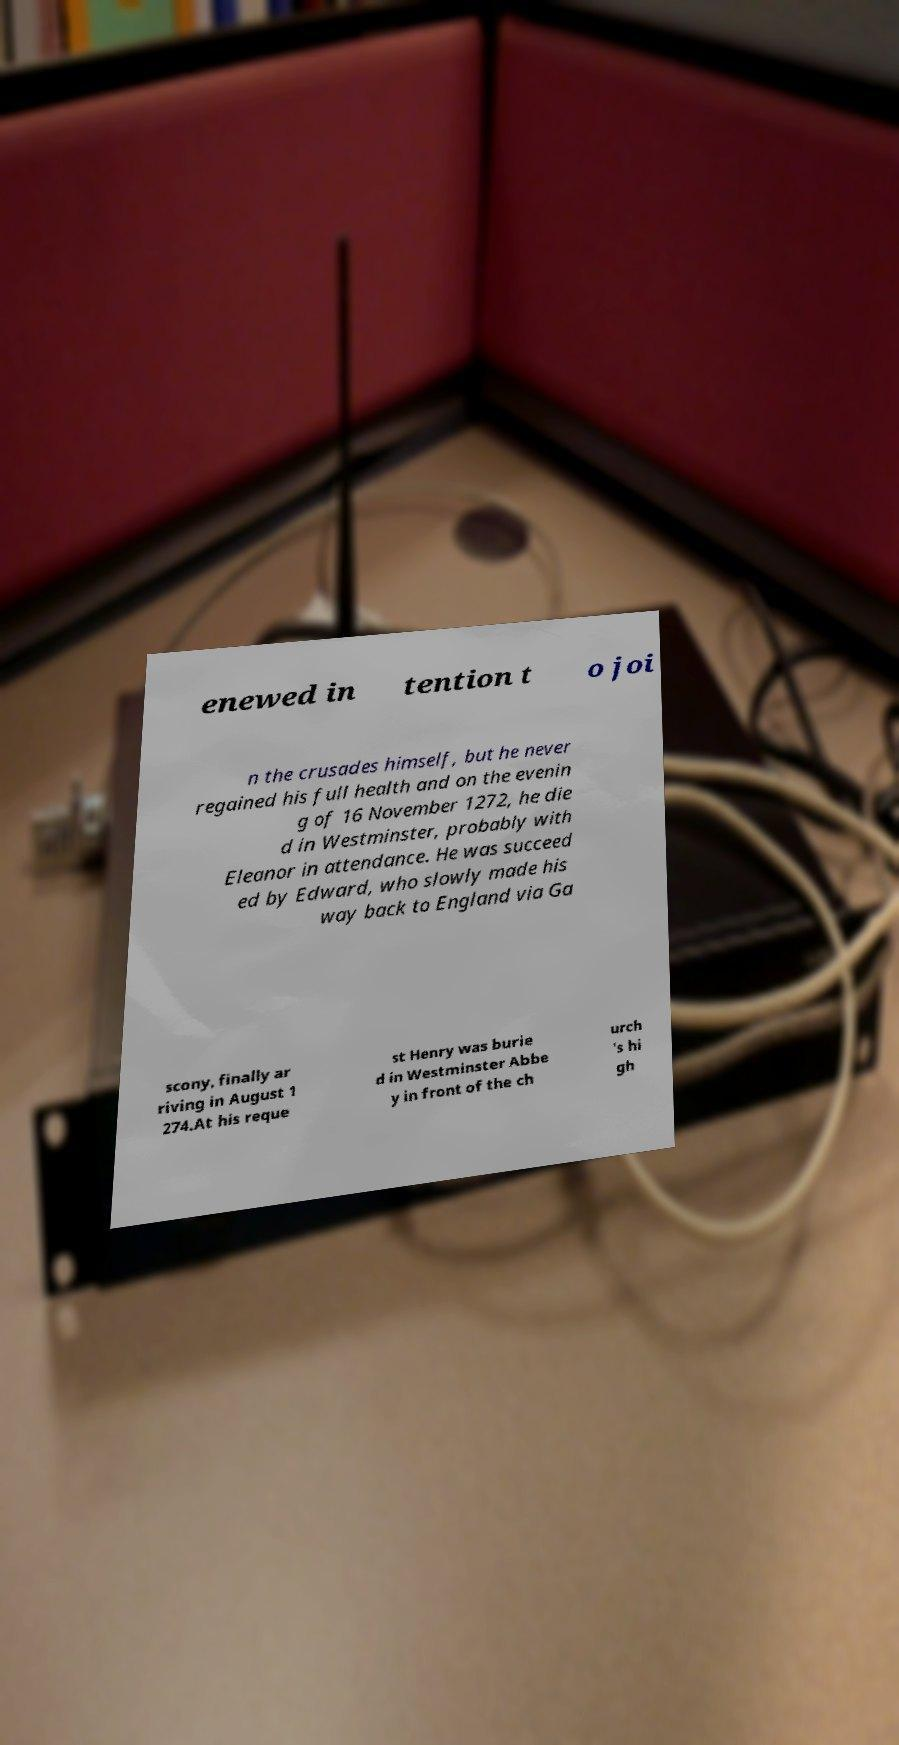There's text embedded in this image that I need extracted. Can you transcribe it verbatim? enewed in tention t o joi n the crusades himself, but he never regained his full health and on the evenin g of 16 November 1272, he die d in Westminster, probably with Eleanor in attendance. He was succeed ed by Edward, who slowly made his way back to England via Ga scony, finally ar riving in August 1 274.At his reque st Henry was burie d in Westminster Abbe y in front of the ch urch 's hi gh 